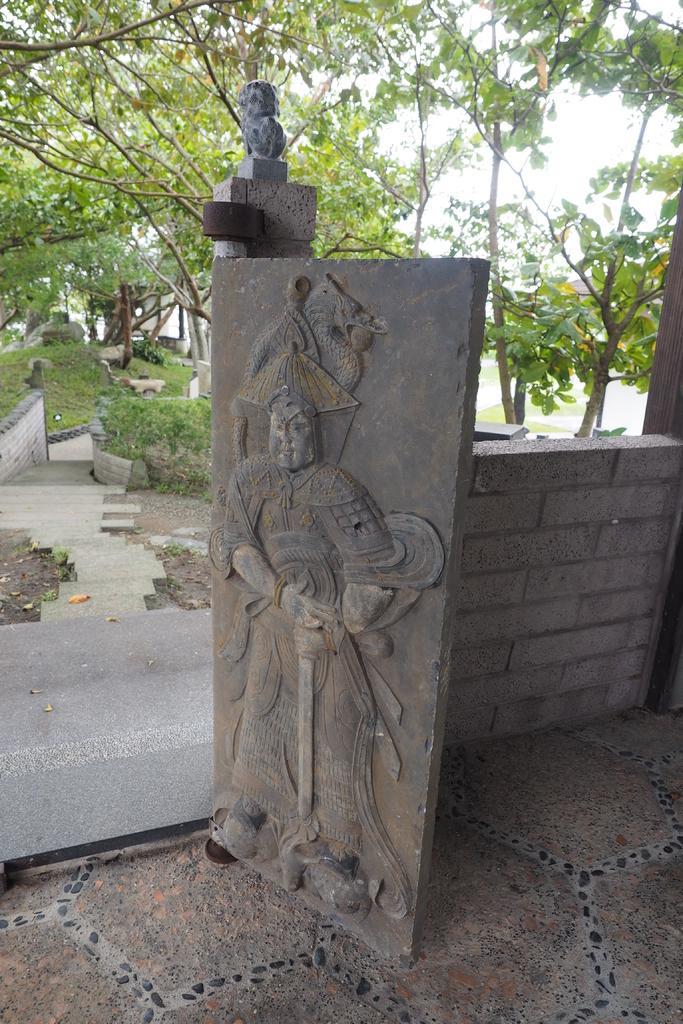How would you summarize this image in a sentence or two? In this picture I can observe carvings on the stone. On the right side I can observe wall. In the background there are trees. 